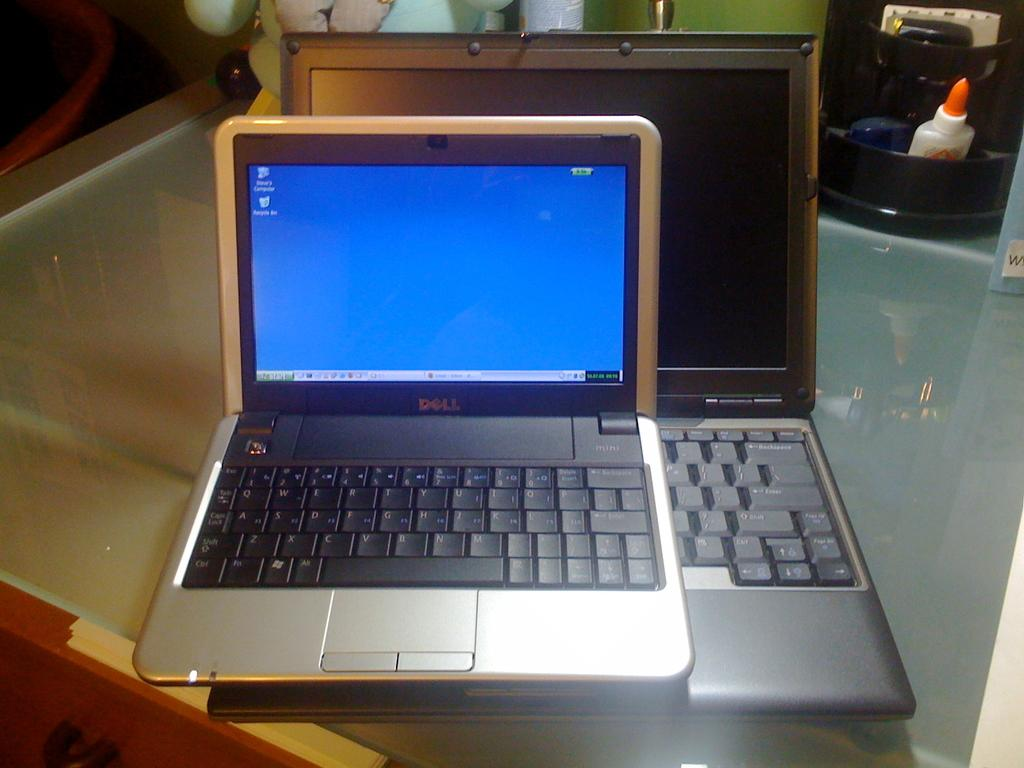<image>
Create a compact narrative representing the image presented. An old Dell computer sits on top of another computer 